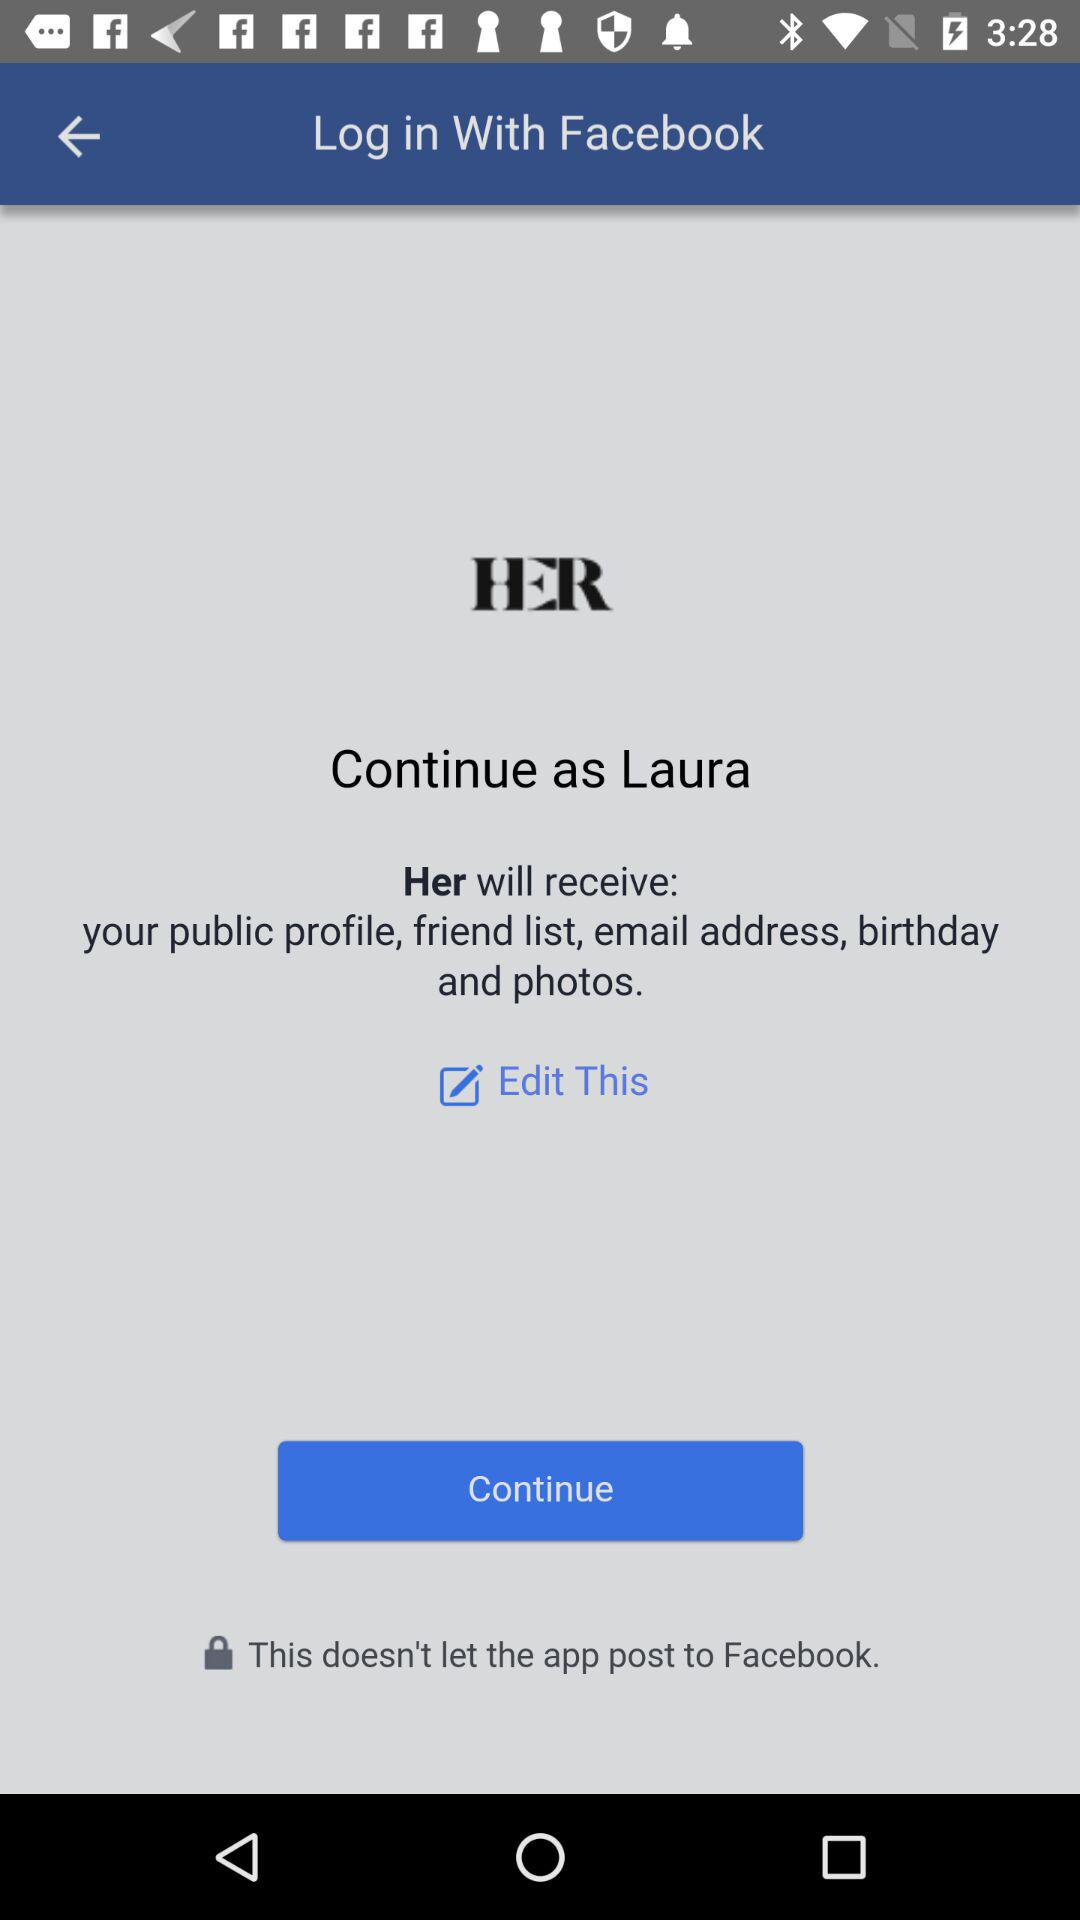What is the name of the user? The name of the user is Laura. 